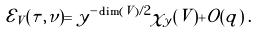<formula> <loc_0><loc_0><loc_500><loc_500>\mathcal { E } _ { V } ( \tau , \nu ) = y ^ { - \dim ( V ) / 2 } \chi _ { y } ( V ) + O ( q ) \, .</formula> 